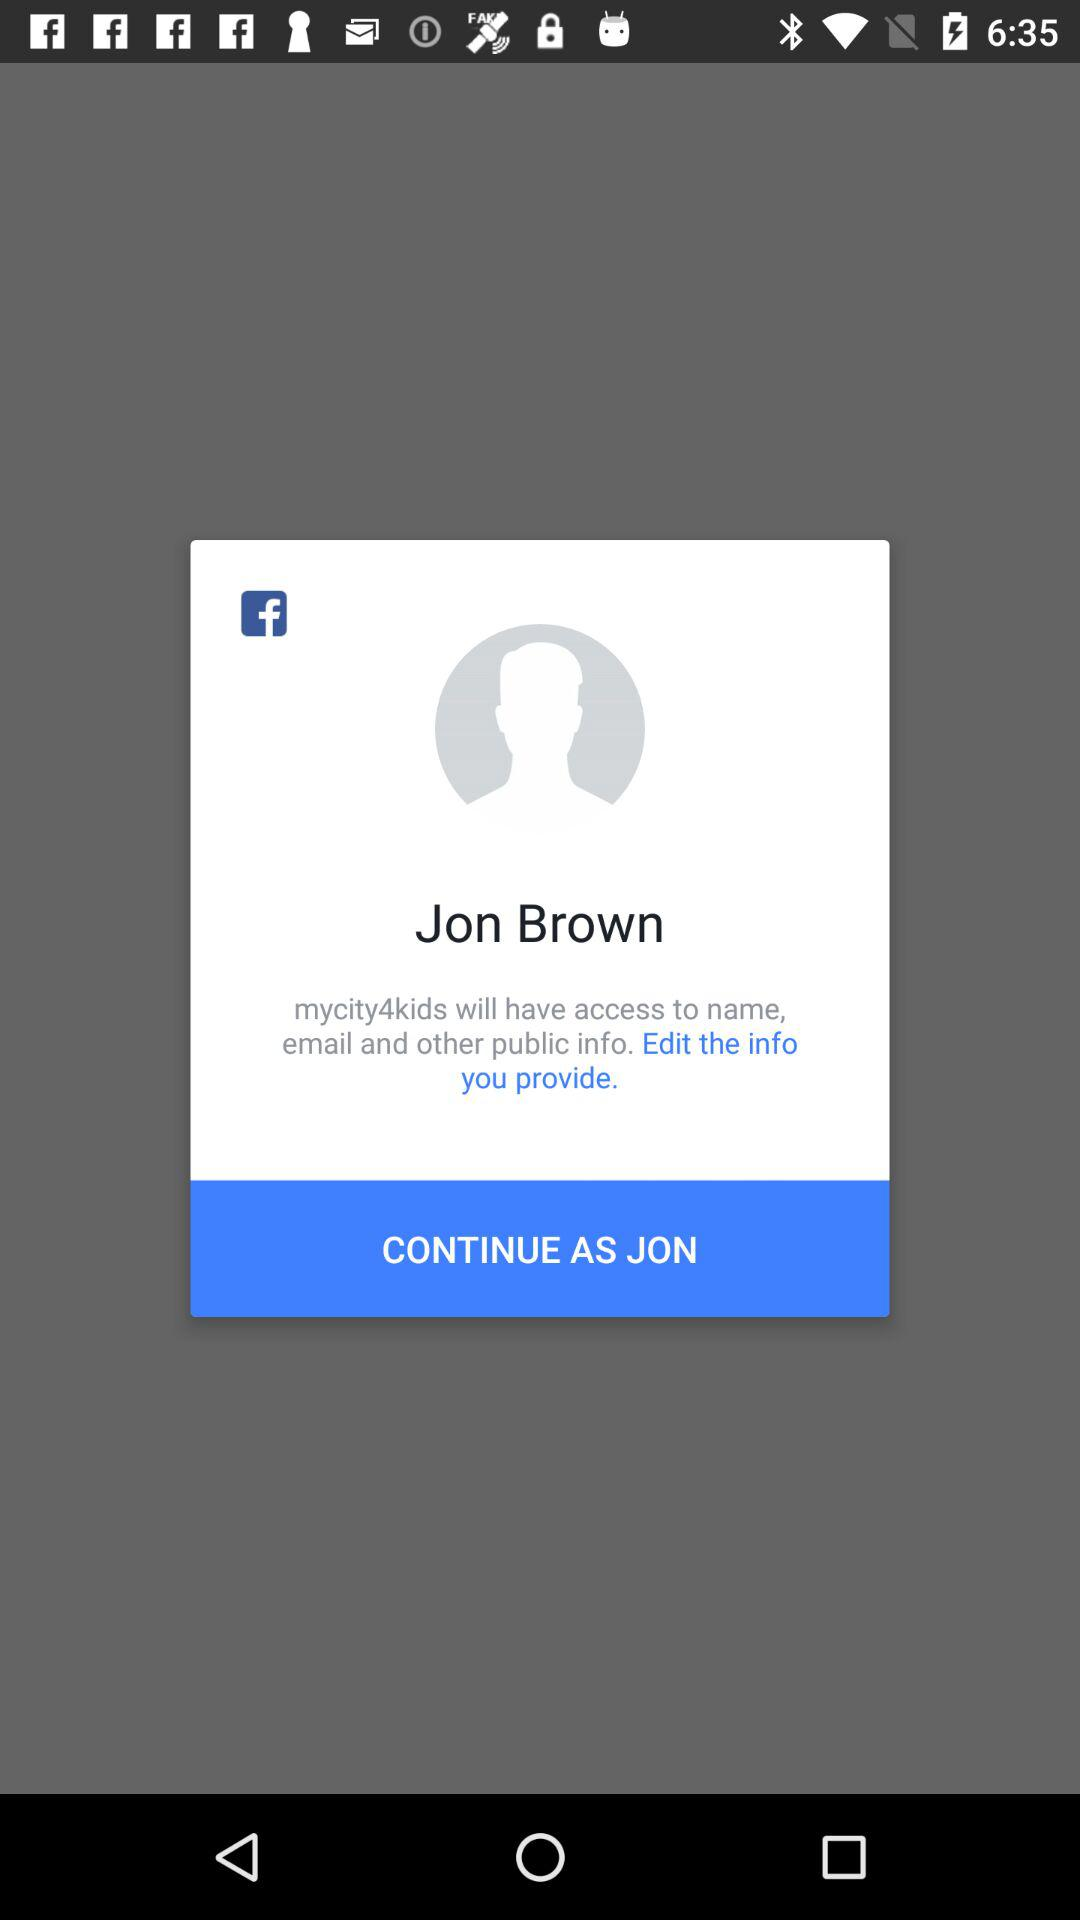What is the login name? The login name is Jon Brown. 